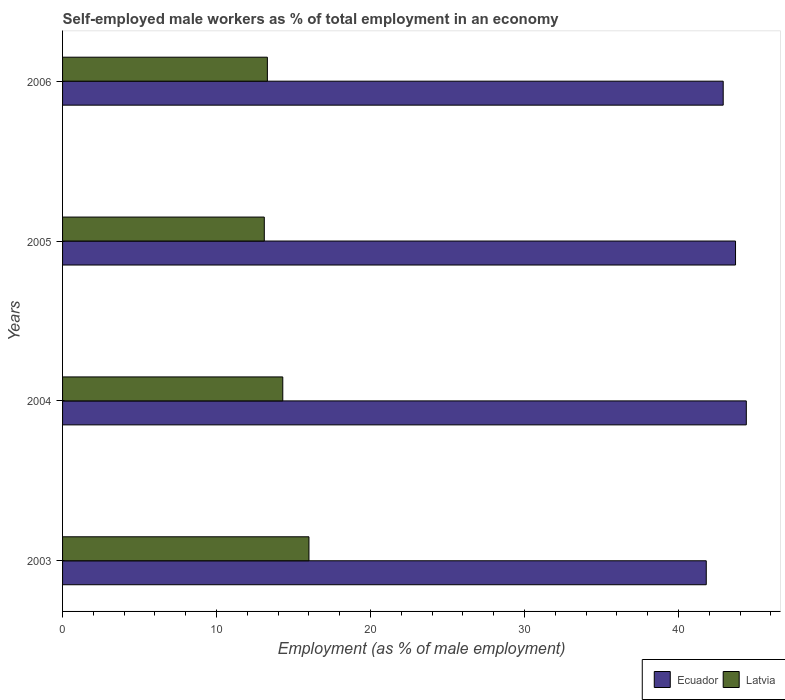Are the number of bars on each tick of the Y-axis equal?
Offer a very short reply. Yes. What is the label of the 2nd group of bars from the top?
Your answer should be compact. 2005. In how many cases, is the number of bars for a given year not equal to the number of legend labels?
Provide a succinct answer. 0. What is the percentage of self-employed male workers in Latvia in 2004?
Make the answer very short. 14.3. Across all years, what is the maximum percentage of self-employed male workers in Latvia?
Make the answer very short. 16. Across all years, what is the minimum percentage of self-employed male workers in Ecuador?
Your answer should be compact. 41.8. What is the total percentage of self-employed male workers in Latvia in the graph?
Give a very brief answer. 56.7. What is the difference between the percentage of self-employed male workers in Latvia in 2003 and that in 2005?
Offer a very short reply. 2.9. What is the difference between the percentage of self-employed male workers in Ecuador in 2004 and the percentage of self-employed male workers in Latvia in 2003?
Make the answer very short. 28.4. What is the average percentage of self-employed male workers in Ecuador per year?
Provide a succinct answer. 43.2. In the year 2003, what is the difference between the percentage of self-employed male workers in Latvia and percentage of self-employed male workers in Ecuador?
Offer a terse response. -25.8. In how many years, is the percentage of self-employed male workers in Latvia greater than 28 %?
Ensure brevity in your answer.  0. What is the ratio of the percentage of self-employed male workers in Ecuador in 2003 to that in 2005?
Provide a succinct answer. 0.96. Is the percentage of self-employed male workers in Latvia in 2003 less than that in 2004?
Keep it short and to the point. No. Is the difference between the percentage of self-employed male workers in Latvia in 2003 and 2006 greater than the difference between the percentage of self-employed male workers in Ecuador in 2003 and 2006?
Offer a very short reply. Yes. What is the difference between the highest and the second highest percentage of self-employed male workers in Ecuador?
Provide a short and direct response. 0.7. What is the difference between the highest and the lowest percentage of self-employed male workers in Latvia?
Make the answer very short. 2.9. In how many years, is the percentage of self-employed male workers in Ecuador greater than the average percentage of self-employed male workers in Ecuador taken over all years?
Ensure brevity in your answer.  2. Is the sum of the percentage of self-employed male workers in Ecuador in 2005 and 2006 greater than the maximum percentage of self-employed male workers in Latvia across all years?
Give a very brief answer. Yes. What does the 2nd bar from the top in 2005 represents?
Make the answer very short. Ecuador. What does the 1st bar from the bottom in 2006 represents?
Offer a very short reply. Ecuador. How many bars are there?
Your response must be concise. 8. Are all the bars in the graph horizontal?
Provide a succinct answer. Yes. What is the difference between two consecutive major ticks on the X-axis?
Provide a succinct answer. 10. Does the graph contain any zero values?
Provide a short and direct response. No. How many legend labels are there?
Your answer should be compact. 2. What is the title of the graph?
Keep it short and to the point. Self-employed male workers as % of total employment in an economy. What is the label or title of the X-axis?
Offer a terse response. Employment (as % of male employment). What is the label or title of the Y-axis?
Your answer should be very brief. Years. What is the Employment (as % of male employment) in Ecuador in 2003?
Ensure brevity in your answer.  41.8. What is the Employment (as % of male employment) of Latvia in 2003?
Keep it short and to the point. 16. What is the Employment (as % of male employment) in Ecuador in 2004?
Ensure brevity in your answer.  44.4. What is the Employment (as % of male employment) of Latvia in 2004?
Provide a succinct answer. 14.3. What is the Employment (as % of male employment) of Ecuador in 2005?
Give a very brief answer. 43.7. What is the Employment (as % of male employment) of Latvia in 2005?
Ensure brevity in your answer.  13.1. What is the Employment (as % of male employment) in Ecuador in 2006?
Your answer should be compact. 42.9. What is the Employment (as % of male employment) of Latvia in 2006?
Make the answer very short. 13.3. Across all years, what is the maximum Employment (as % of male employment) of Ecuador?
Make the answer very short. 44.4. Across all years, what is the maximum Employment (as % of male employment) in Latvia?
Ensure brevity in your answer.  16. Across all years, what is the minimum Employment (as % of male employment) of Ecuador?
Your response must be concise. 41.8. Across all years, what is the minimum Employment (as % of male employment) of Latvia?
Your answer should be very brief. 13.1. What is the total Employment (as % of male employment) of Ecuador in the graph?
Ensure brevity in your answer.  172.8. What is the total Employment (as % of male employment) in Latvia in the graph?
Make the answer very short. 56.7. What is the difference between the Employment (as % of male employment) in Ecuador in 2003 and that in 2004?
Offer a very short reply. -2.6. What is the difference between the Employment (as % of male employment) of Ecuador in 2003 and that in 2005?
Offer a terse response. -1.9. What is the difference between the Employment (as % of male employment) in Latvia in 2003 and that in 2005?
Give a very brief answer. 2.9. What is the difference between the Employment (as % of male employment) in Latvia in 2003 and that in 2006?
Make the answer very short. 2.7. What is the difference between the Employment (as % of male employment) in Latvia in 2004 and that in 2005?
Ensure brevity in your answer.  1.2. What is the difference between the Employment (as % of male employment) of Ecuador in 2005 and that in 2006?
Provide a short and direct response. 0.8. What is the difference between the Employment (as % of male employment) of Latvia in 2005 and that in 2006?
Offer a terse response. -0.2. What is the difference between the Employment (as % of male employment) of Ecuador in 2003 and the Employment (as % of male employment) of Latvia in 2004?
Ensure brevity in your answer.  27.5. What is the difference between the Employment (as % of male employment) of Ecuador in 2003 and the Employment (as % of male employment) of Latvia in 2005?
Provide a short and direct response. 28.7. What is the difference between the Employment (as % of male employment) in Ecuador in 2003 and the Employment (as % of male employment) in Latvia in 2006?
Make the answer very short. 28.5. What is the difference between the Employment (as % of male employment) of Ecuador in 2004 and the Employment (as % of male employment) of Latvia in 2005?
Provide a short and direct response. 31.3. What is the difference between the Employment (as % of male employment) in Ecuador in 2004 and the Employment (as % of male employment) in Latvia in 2006?
Make the answer very short. 31.1. What is the difference between the Employment (as % of male employment) of Ecuador in 2005 and the Employment (as % of male employment) of Latvia in 2006?
Ensure brevity in your answer.  30.4. What is the average Employment (as % of male employment) in Ecuador per year?
Keep it short and to the point. 43.2. What is the average Employment (as % of male employment) of Latvia per year?
Provide a short and direct response. 14.18. In the year 2003, what is the difference between the Employment (as % of male employment) of Ecuador and Employment (as % of male employment) of Latvia?
Your response must be concise. 25.8. In the year 2004, what is the difference between the Employment (as % of male employment) of Ecuador and Employment (as % of male employment) of Latvia?
Provide a succinct answer. 30.1. In the year 2005, what is the difference between the Employment (as % of male employment) in Ecuador and Employment (as % of male employment) in Latvia?
Ensure brevity in your answer.  30.6. In the year 2006, what is the difference between the Employment (as % of male employment) of Ecuador and Employment (as % of male employment) of Latvia?
Offer a very short reply. 29.6. What is the ratio of the Employment (as % of male employment) of Ecuador in 2003 to that in 2004?
Ensure brevity in your answer.  0.94. What is the ratio of the Employment (as % of male employment) of Latvia in 2003 to that in 2004?
Offer a terse response. 1.12. What is the ratio of the Employment (as % of male employment) of Ecuador in 2003 to that in 2005?
Provide a succinct answer. 0.96. What is the ratio of the Employment (as % of male employment) in Latvia in 2003 to that in 2005?
Your response must be concise. 1.22. What is the ratio of the Employment (as % of male employment) of Ecuador in 2003 to that in 2006?
Provide a succinct answer. 0.97. What is the ratio of the Employment (as % of male employment) of Latvia in 2003 to that in 2006?
Offer a very short reply. 1.2. What is the ratio of the Employment (as % of male employment) of Latvia in 2004 to that in 2005?
Give a very brief answer. 1.09. What is the ratio of the Employment (as % of male employment) of Ecuador in 2004 to that in 2006?
Your response must be concise. 1.03. What is the ratio of the Employment (as % of male employment) in Latvia in 2004 to that in 2006?
Your answer should be very brief. 1.08. What is the ratio of the Employment (as % of male employment) of Ecuador in 2005 to that in 2006?
Your answer should be very brief. 1.02. What is the difference between the highest and the second highest Employment (as % of male employment) in Ecuador?
Make the answer very short. 0.7. What is the difference between the highest and the second highest Employment (as % of male employment) in Latvia?
Your answer should be compact. 1.7. 